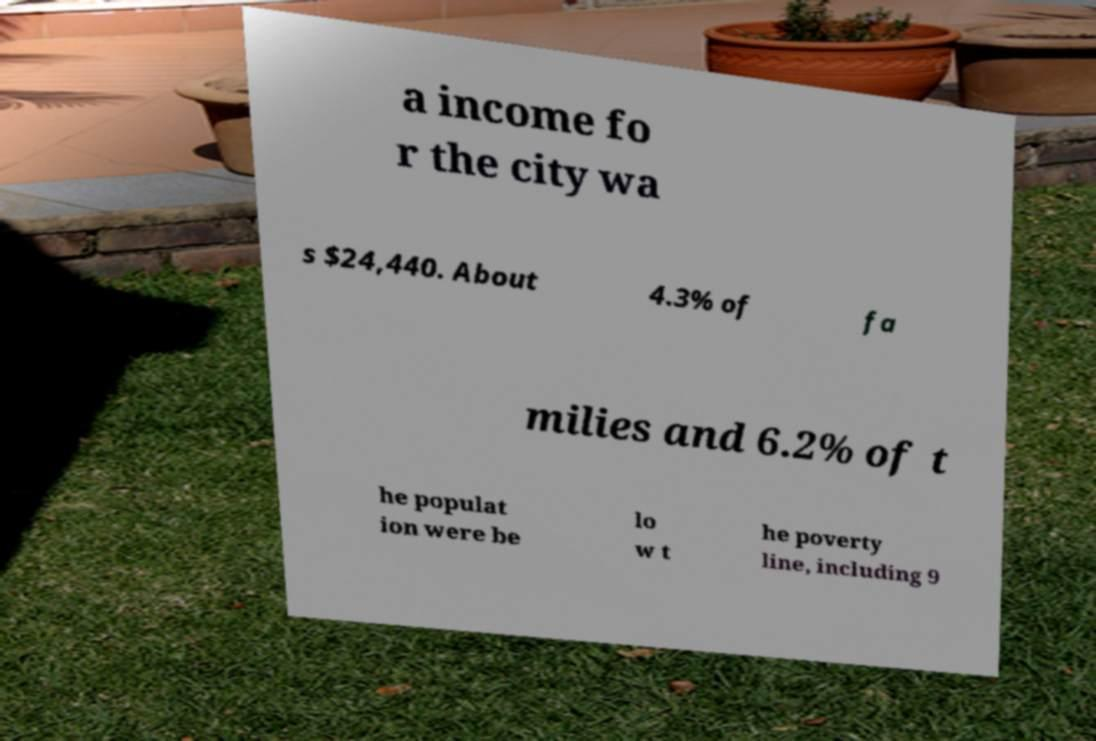Please identify and transcribe the text found in this image. a income fo r the city wa s $24,440. About 4.3% of fa milies and 6.2% of t he populat ion were be lo w t he poverty line, including 9 